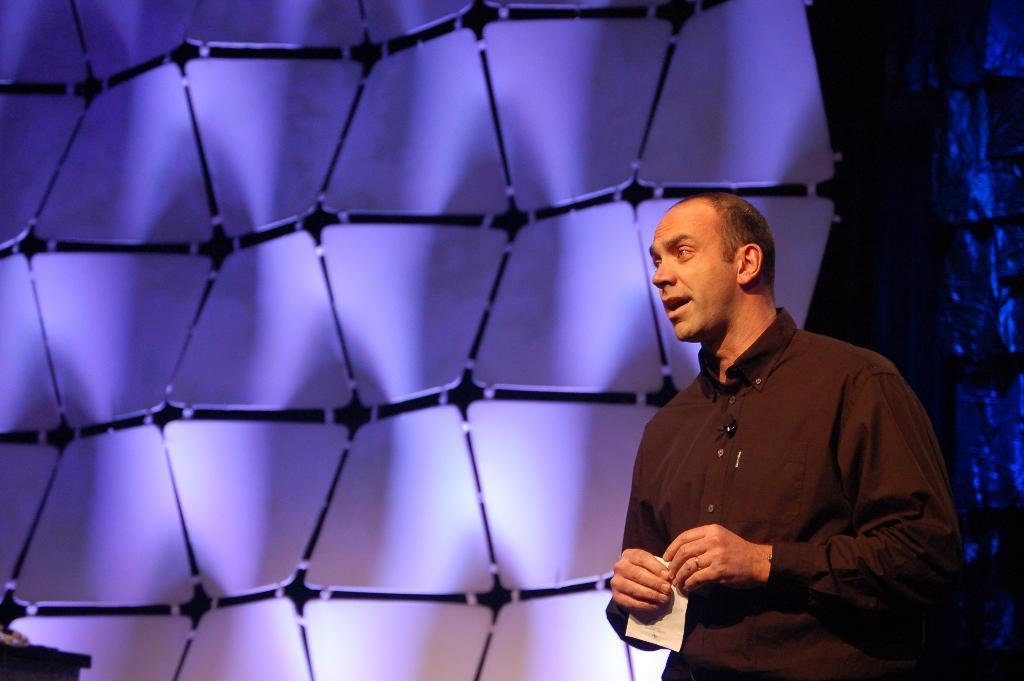What is the person in the image doing? The person is on a stage and talking. What might the person be holding in their hand? The person is holding a paper. What is behind the person on the stage? There is a wall behind the person. What can be seen on the wall? Lighting falls on the wall. How does the person in the image address the issue of pollution? The image does not show the person addressing any issue related to pollution. 